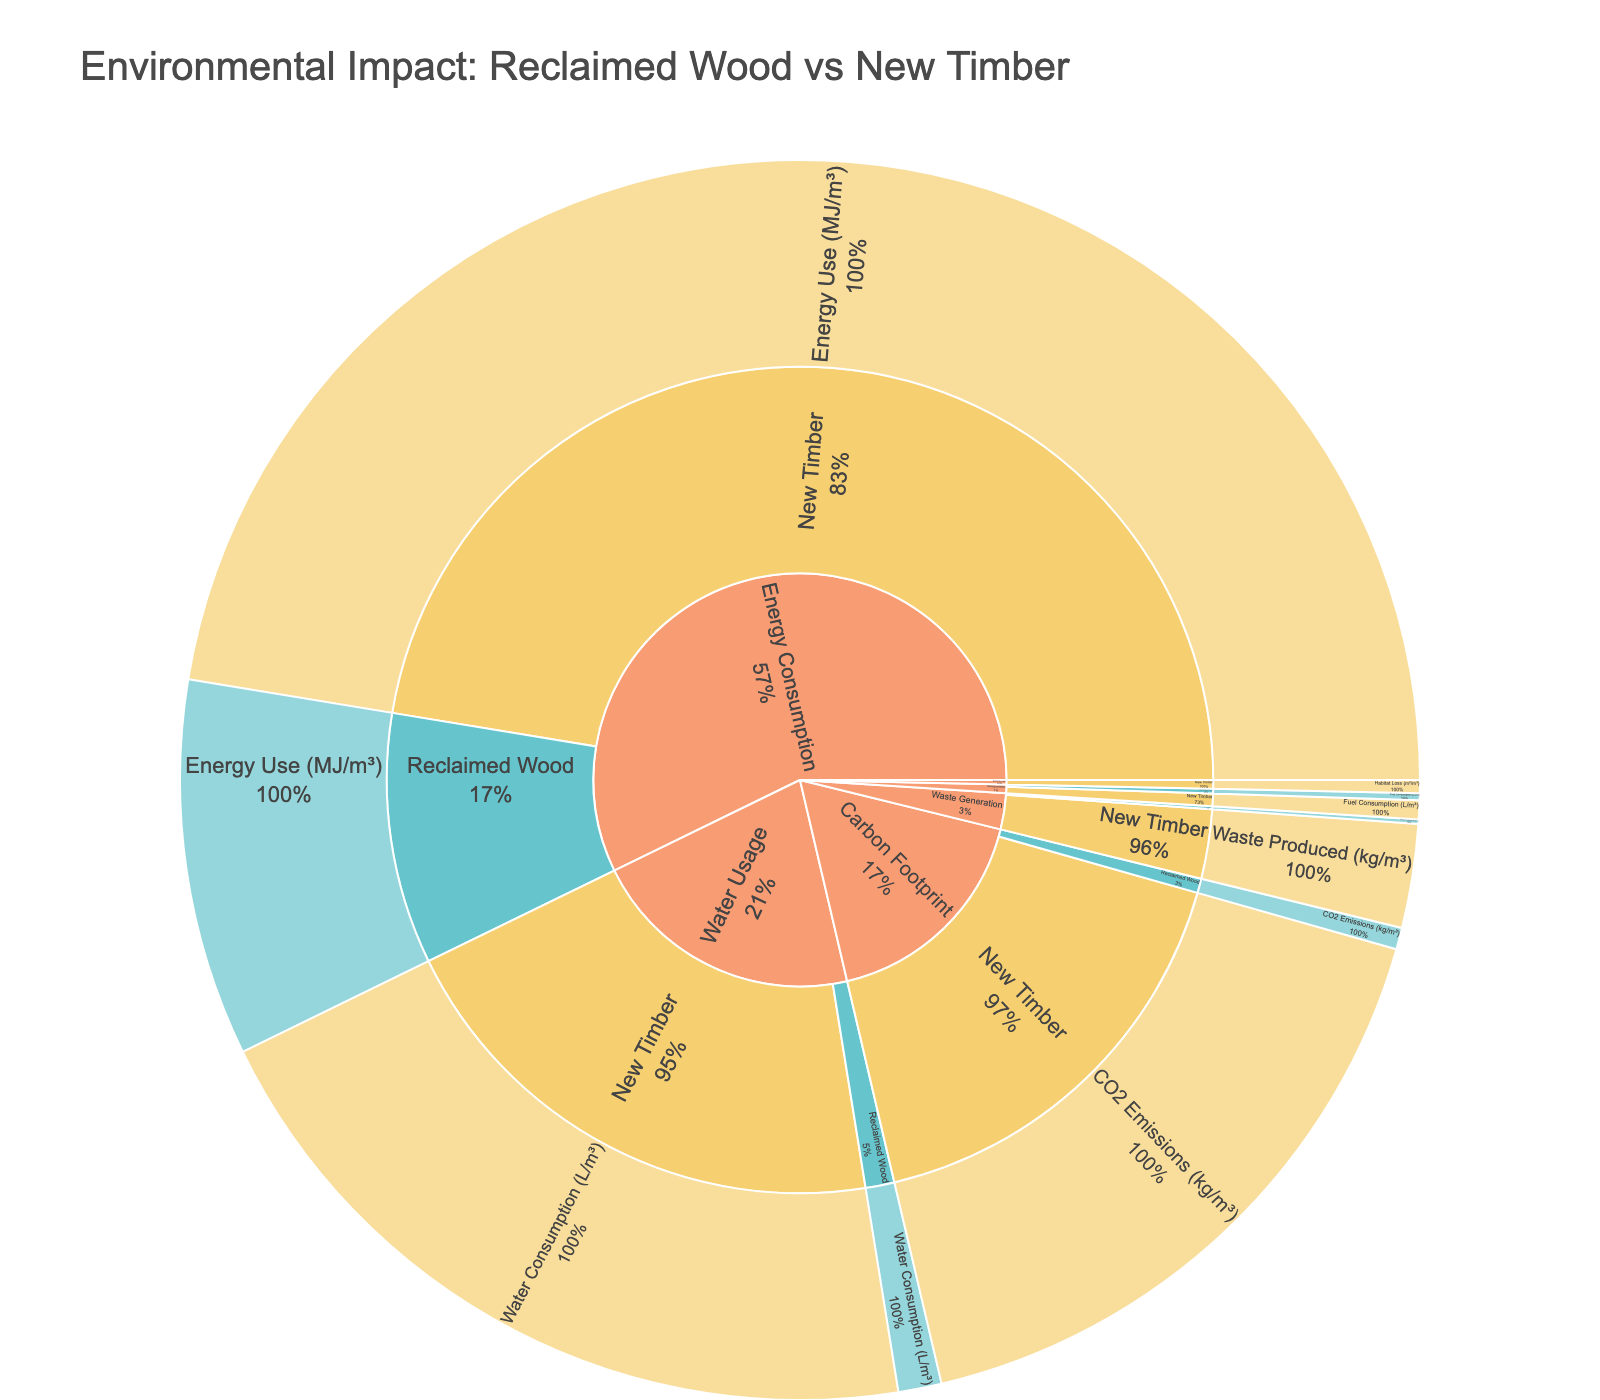What's the title of the plot? The title is usually displayed prominently at the top of the plot. Here, it indicates the overarching theme of the data presented.
Answer: Environmental Impact: Reclaimed Wood vs New Timber How much CO2 emissions do New Timber and Reclaimed Wood produce per cubic meter? By looking at the "Carbon Footprint" category, we can see that New Timber has a value of 750 kg/m³, and Reclaimed Wood has a value of 25 kg/m³ for CO2 emissions.
Answer: New Timber: 750 kg/m³, Reclaimed Wood: 25 kg/m³ Which category shows the largest difference between New Timber and Reclaimed Wood in terms of environmental impact? By comparing the values across categories, the largest difference is observed in the "Carbon Footprint" category where New Timber emits 750 kg/m³ of CO2, and Reclaimed Wood emits only 25 kg/m³.
Answer: Carbon Footprint What is the total energy consumption for both New Timber and Reclaimed Wood combined? Add the energy consumption values for both materials: New Timber uses 2100 MJ/m³ and Reclaimed Wood uses 435 MJ/m³. Summing these values gives us 2100 + 435 = 2535 MJ/m³.
Answer: 2535 MJ/m³ How does waste production in New Timber compare to that in Reclaimed Wood? In the "Waste Generation" category, New Timber produces 120 kg/m³ of waste while Reclaimed Wood produces only 5 kg/m³.
Answer: New Timber produces 115 kg/m³ more waste than Reclaimed Wood What percentage of the total waste generated by both materials does Reclaimed Wood contribute? Total waste is 120 kg/m³ (New Timber) + 5 kg/m³ (Reclaimed Wood) = 125 kg/m³. The percentage for Reclaimed Wood is (5 / 125) * 100 = 4%.
Answer: 4% How much more water does New Timber consume compared to Reclaimed Wood? In the "Water Usage" category, New Timber consumes 900 L/m³ while Reclaimed Wood consumes 50 L/m³. The difference is 900 - 50 = 850 L/m³.
Answer: 850 L/m³ In which category does Reclaimed Wood have the smallest environmental impact compared to New Timber? By examining all categories, we see that "Biodiversity Impact" shows no habitat loss (0 m²/m³) for Reclaimed Wood, whereas New Timber has a habitat loss of 15 m²/m³.
Answer: Biodiversity Impact What is the average fuel consumption for transportation in New Timber and Reclaimed Wood? Add the fuel consumption values for both: New Timber uses 22 L/m³ and Reclaimed Wood uses 8 L/m³. Average is (22 + 8) / 2 = 15 L/m³.
Answer: 15 L/m³ 